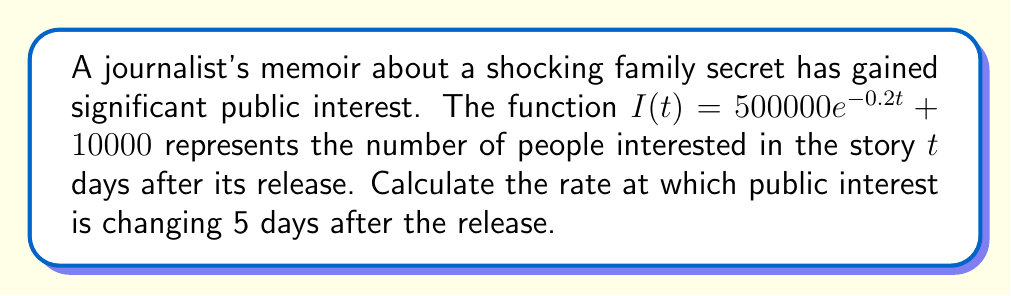Can you answer this question? To find the rate of change in public interest over time, we need to calculate the derivative of the given function $I(t)$ and then evaluate it at $t = 5$.

1. The given function is:
   $I(t) = 500000e^{-0.2t} + 10000$

2. To find the derivative, we apply the sum rule and the chain rule:
   $$\frac{dI}{dt} = \frac{d}{dt}(500000e^{-0.2t}) + \frac{d}{dt}(10000)$$

3. The derivative of a constant (10000) is 0, so:
   $$\frac{dI}{dt} = 500000 \cdot \frac{d}{dt}(e^{-0.2t}) + 0$$

4. Using the chain rule for $e^{-0.2t}$:
   $$\frac{dI}{dt} = 500000 \cdot e^{-0.2t} \cdot (-0.2)$$

5. Simplifying:
   $$\frac{dI}{dt} = -100000e^{-0.2t}$$

6. Now, we evaluate this derivative at $t = 5$:
   $$\frac{dI}{dt}\bigg|_{t=5} = -100000e^{-0.2(5)}$$

7. Calculate the value:
   $$\frac{dI}{dt}\bigg|_{t=5} = -100000e^{-1} \approx -36788$$

The negative sign indicates that the interest is decreasing over time.
Answer: The rate of change in public interest 5 days after the release is approximately -36,788 people per day. 